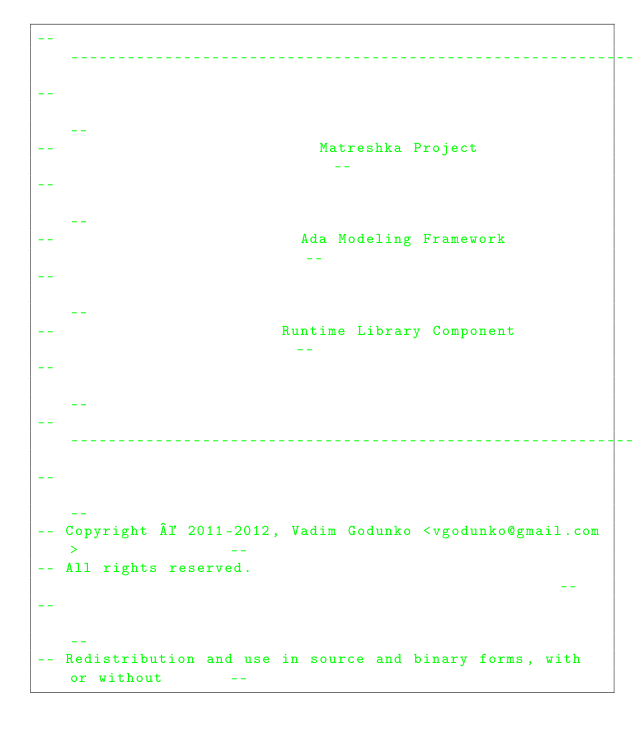<code> <loc_0><loc_0><loc_500><loc_500><_Ada_>------------------------------------------------------------------------------
--                                                                          --
--                            Matreshka Project                             --
--                                                                          --
--                          Ada Modeling Framework                          --
--                                                                          --
--                        Runtime Library Component                         --
--                                                                          --
------------------------------------------------------------------------------
--                                                                          --
-- Copyright © 2011-2012, Vadim Godunko <vgodunko@gmail.com>                --
-- All rights reserved.                                                     --
--                                                                          --
-- Redistribution and use in source and binary forms, with or without       --</code> 